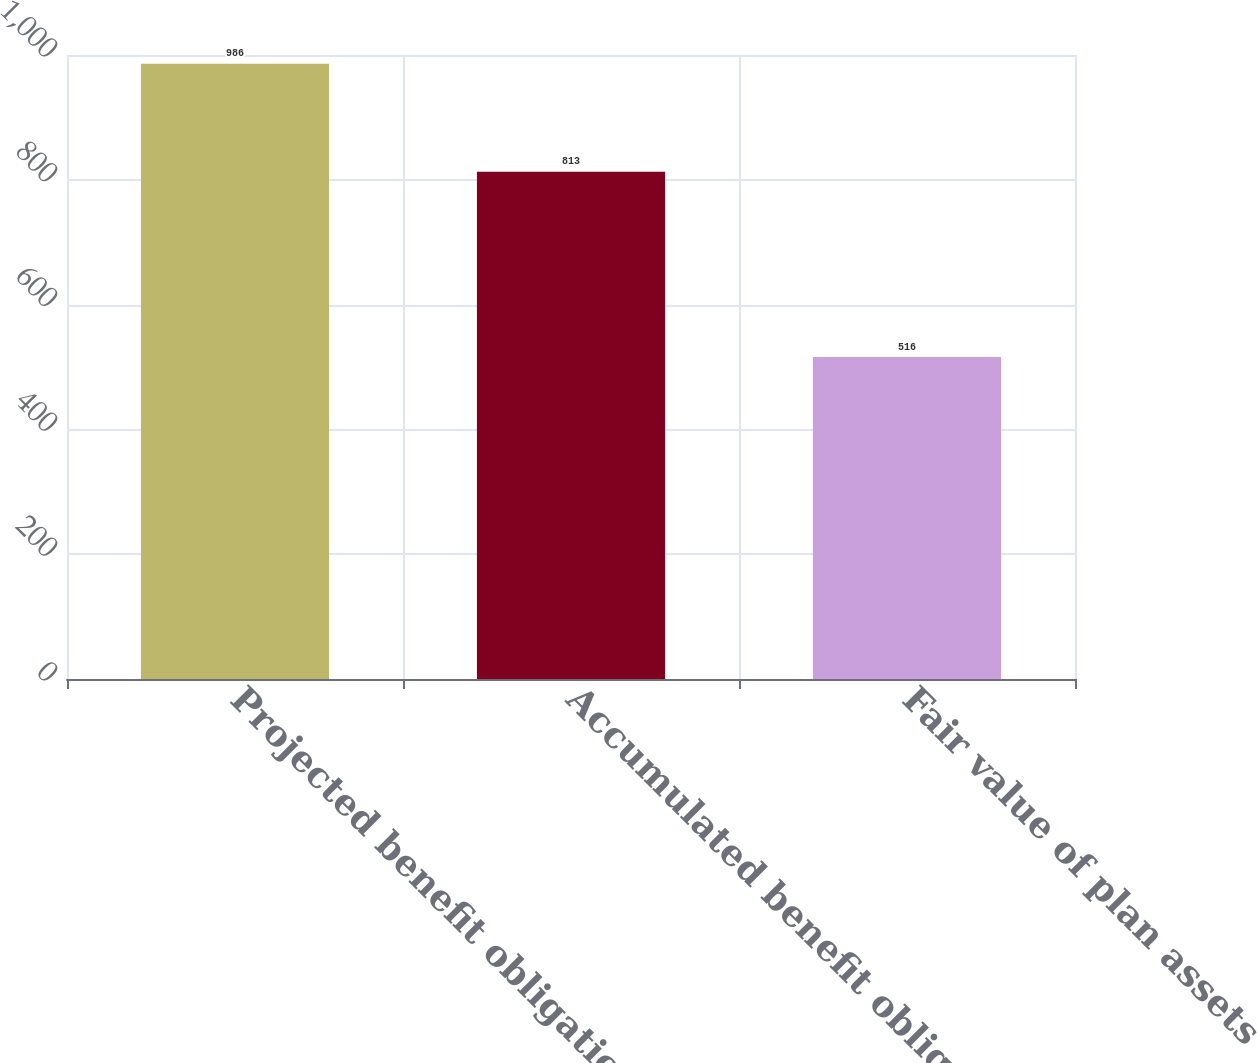<chart> <loc_0><loc_0><loc_500><loc_500><bar_chart><fcel>Projected benefit obligation<fcel>Accumulated benefit obligation<fcel>Fair value of plan assets<nl><fcel>986<fcel>813<fcel>516<nl></chart> 